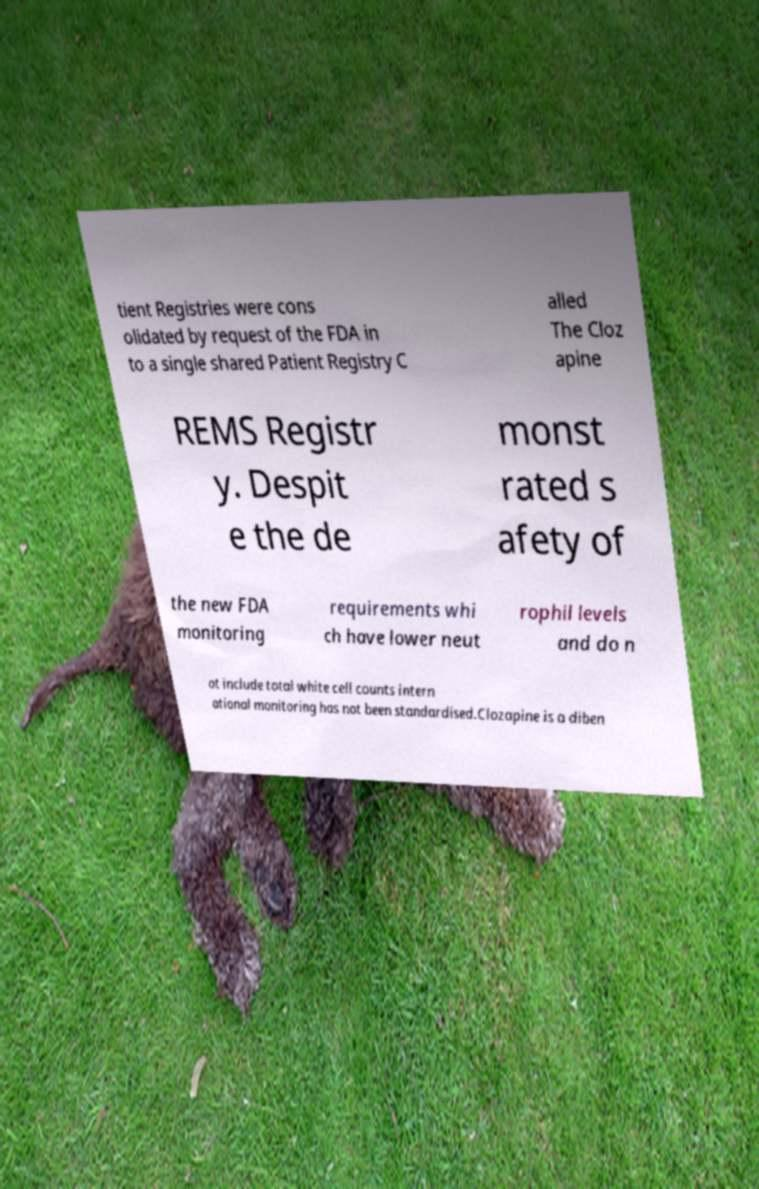What messages or text are displayed in this image? I need them in a readable, typed format. tient Registries were cons olidated by request of the FDA in to a single shared Patient Registry C alled The Cloz apine REMS Registr y. Despit e the de monst rated s afety of the new FDA monitoring requirements whi ch have lower neut rophil levels and do n ot include total white cell counts intern ational monitoring has not been standardised.Clozapine is a diben 